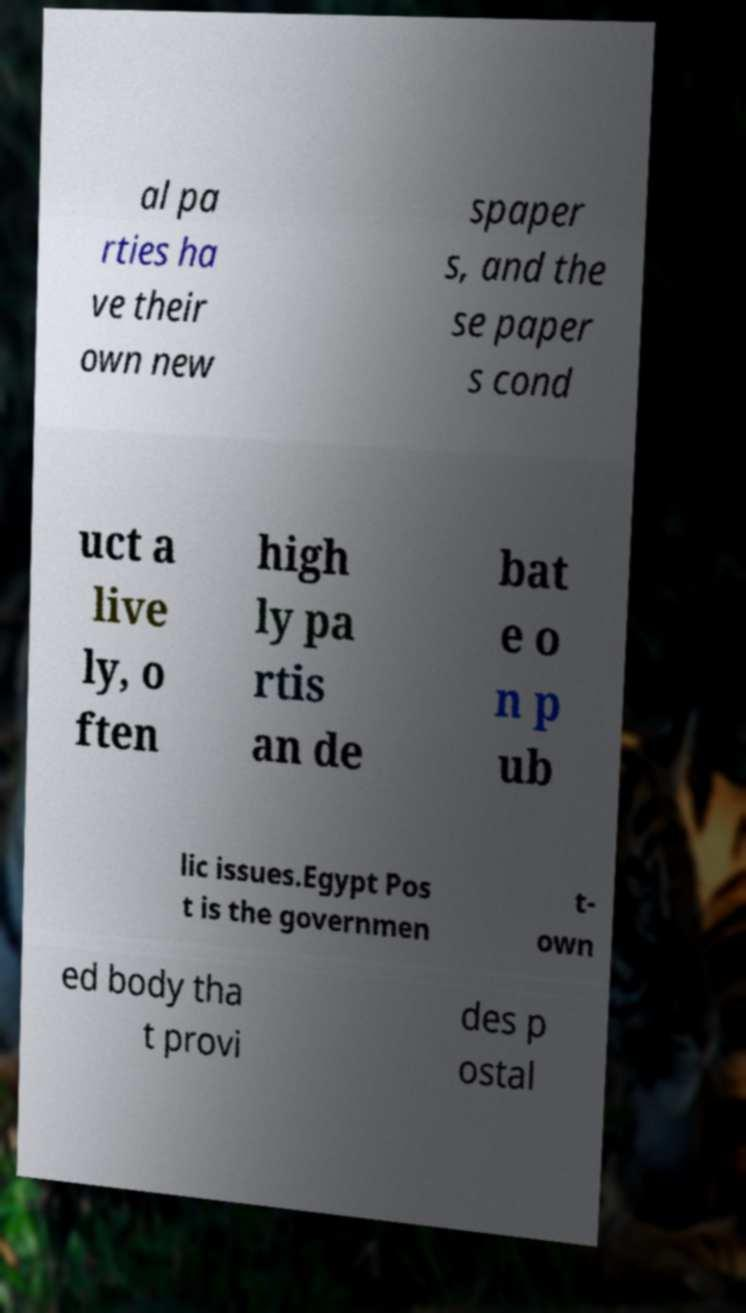For documentation purposes, I need the text within this image transcribed. Could you provide that? al pa rties ha ve their own new spaper s, and the se paper s cond uct a live ly, o ften high ly pa rtis an de bat e o n p ub lic issues.Egypt Pos t is the governmen t- own ed body tha t provi des p ostal 